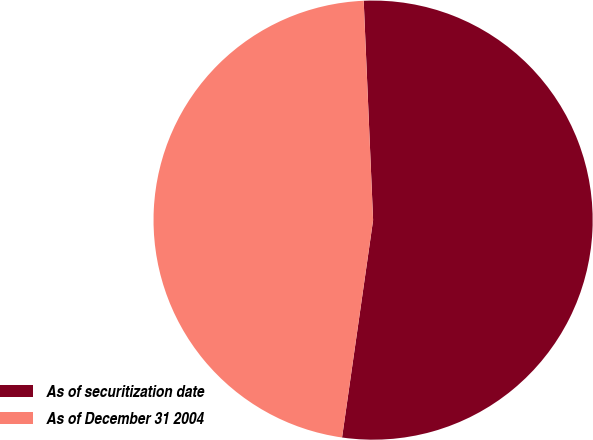<chart> <loc_0><loc_0><loc_500><loc_500><pie_chart><fcel>As of securitization date<fcel>As of December 31 2004<nl><fcel>52.94%<fcel>47.06%<nl></chart> 